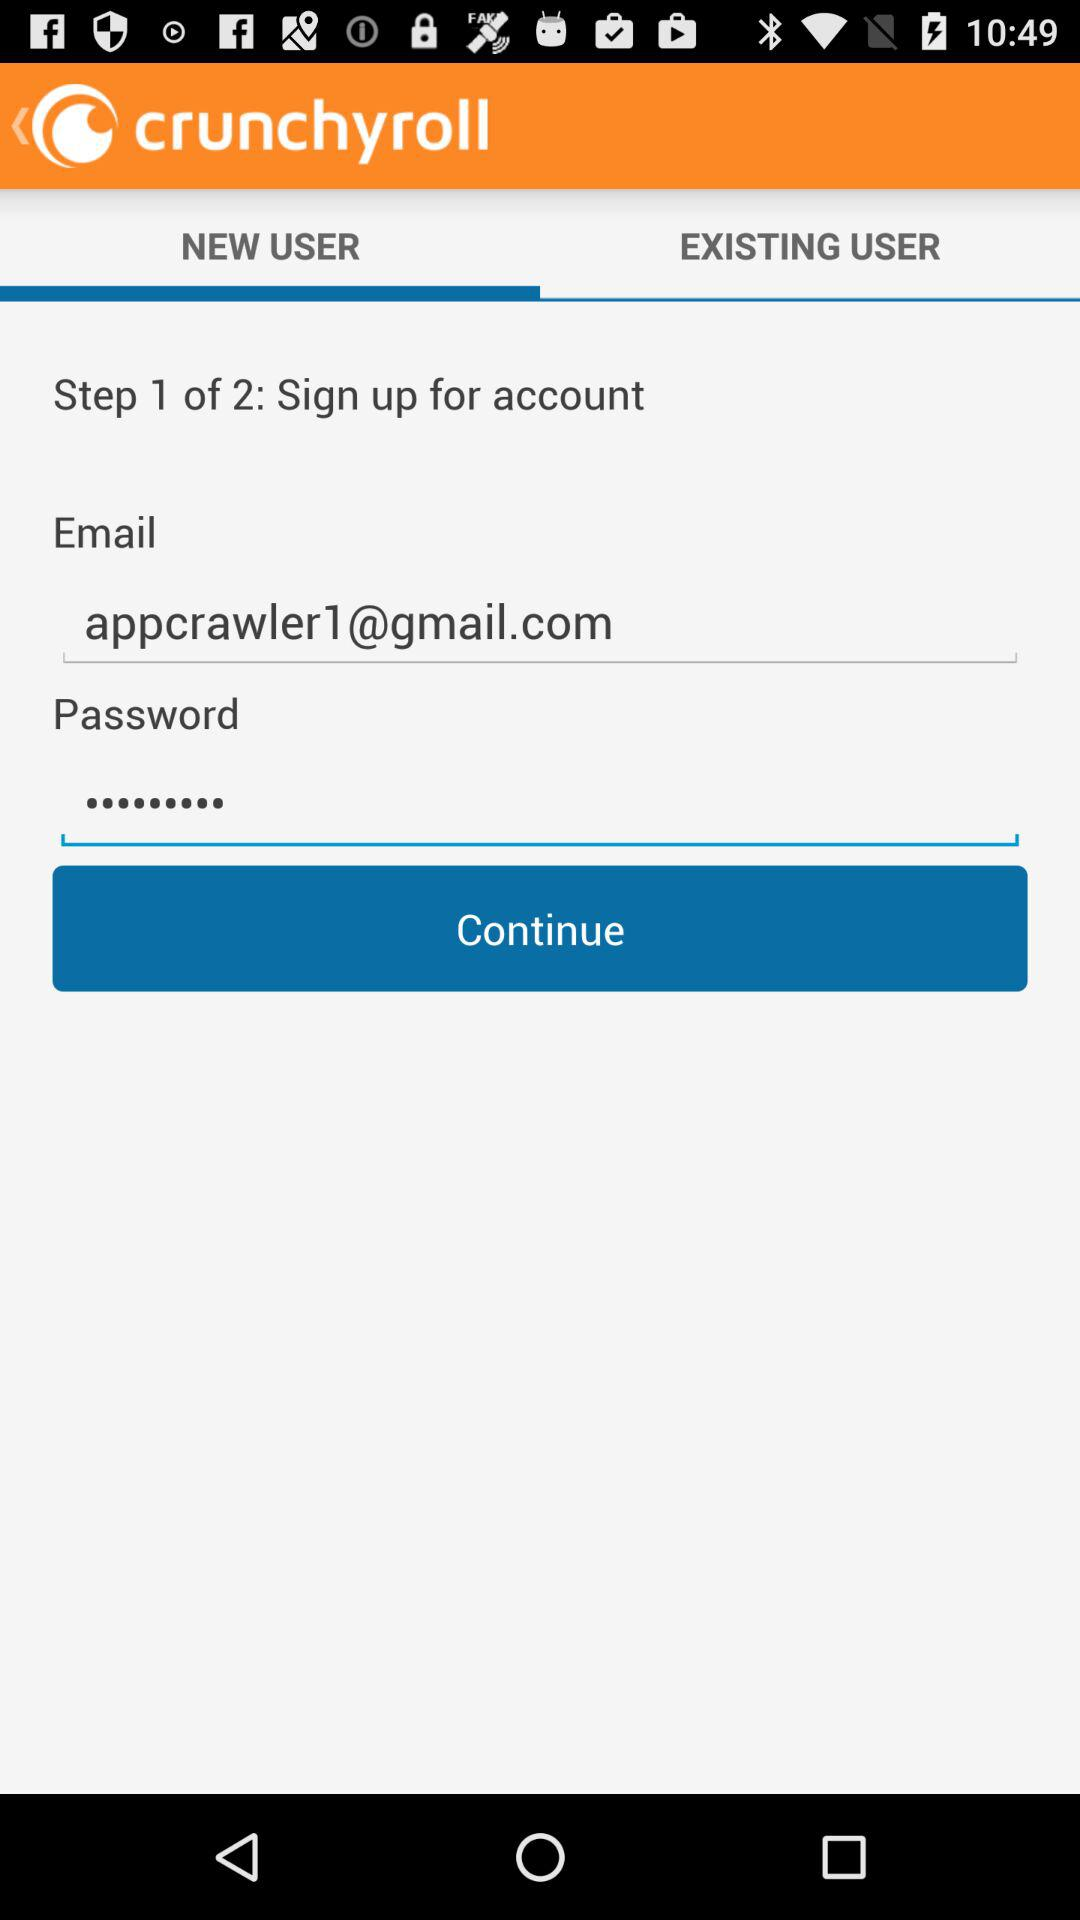Which tab has been selected? The selected tab is "NEW USER". 